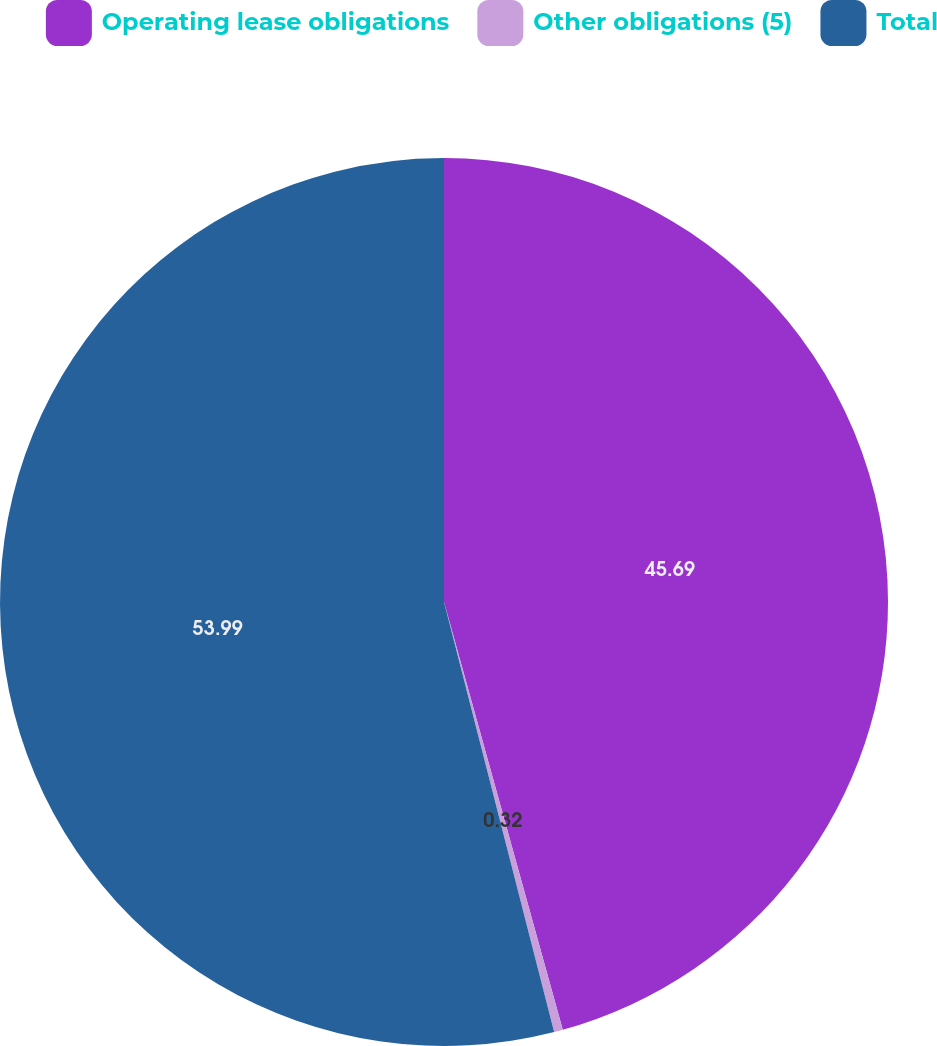Convert chart. <chart><loc_0><loc_0><loc_500><loc_500><pie_chart><fcel>Operating lease obligations<fcel>Other obligations (5)<fcel>Total<nl><fcel>45.69%<fcel>0.32%<fcel>53.99%<nl></chart> 